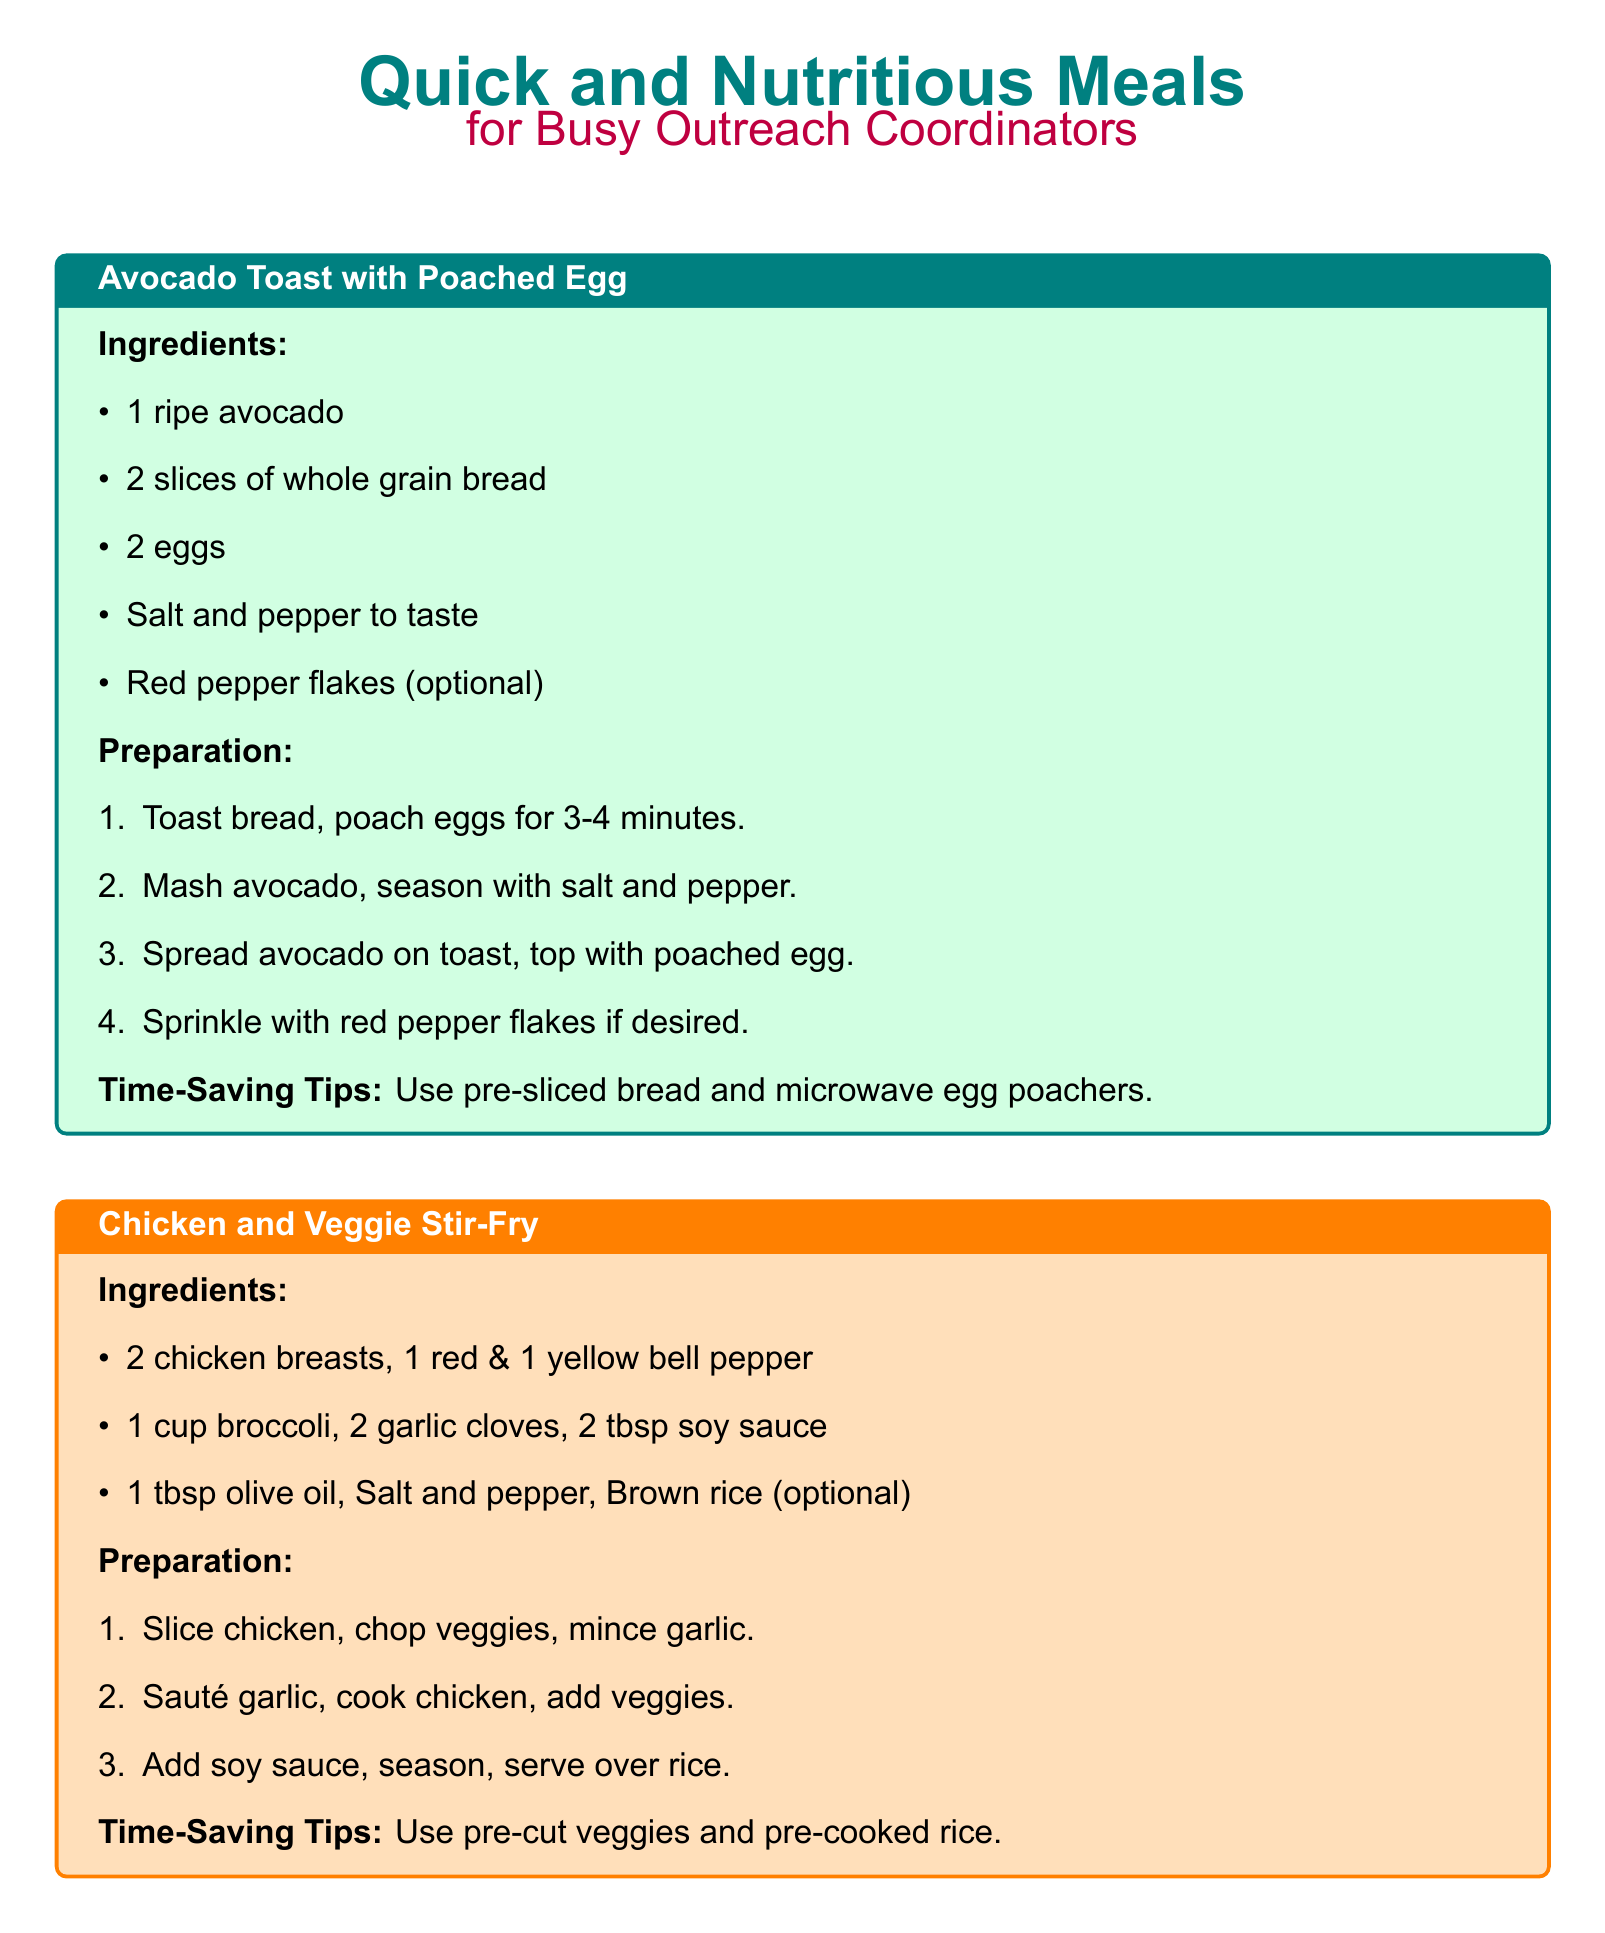what is the first meal listed on the card? The first meal listed is "Avocado Toast with Poached Egg."
Answer: Avocado Toast with Poached Egg how many slices of bread are needed for the Avocado Toast? The recipe specifies 2 slices of whole grain bread are needed.
Answer: 2 slices what type of oil is used in the Chicken and Veggie Stir-Fry? The recipe mentions 1 tablespoon of olive oil is used in the preparation.
Answer: olive oil what is an optional ingredient for the Greek Yogurt Parfait? The recipe states that honey is an optional ingredient.
Answer: honey what is a time-saving tip for the Chicken and Veggie Stir-Fry? The tip suggests using pre-cut veggies and pre-cooked rice to save time.
Answer: pre-cut veggies and pre-cooked rice how many cups of Greek yogurt are needed for the Greek Yogurt Parfait? The recipe requires 1 cup of Greek yogurt.
Answer: 1 cup for how long should the eggs be poached? The instructions indicate that eggs should be poached for 3-4 minutes.
Answer: 3-4 minutes how many garlic cloves are used in the Chicken and Veggie Stir-Fry? The recipe calls for 2 garlic cloves in the dish.
Answer: 2 garlic cloves 